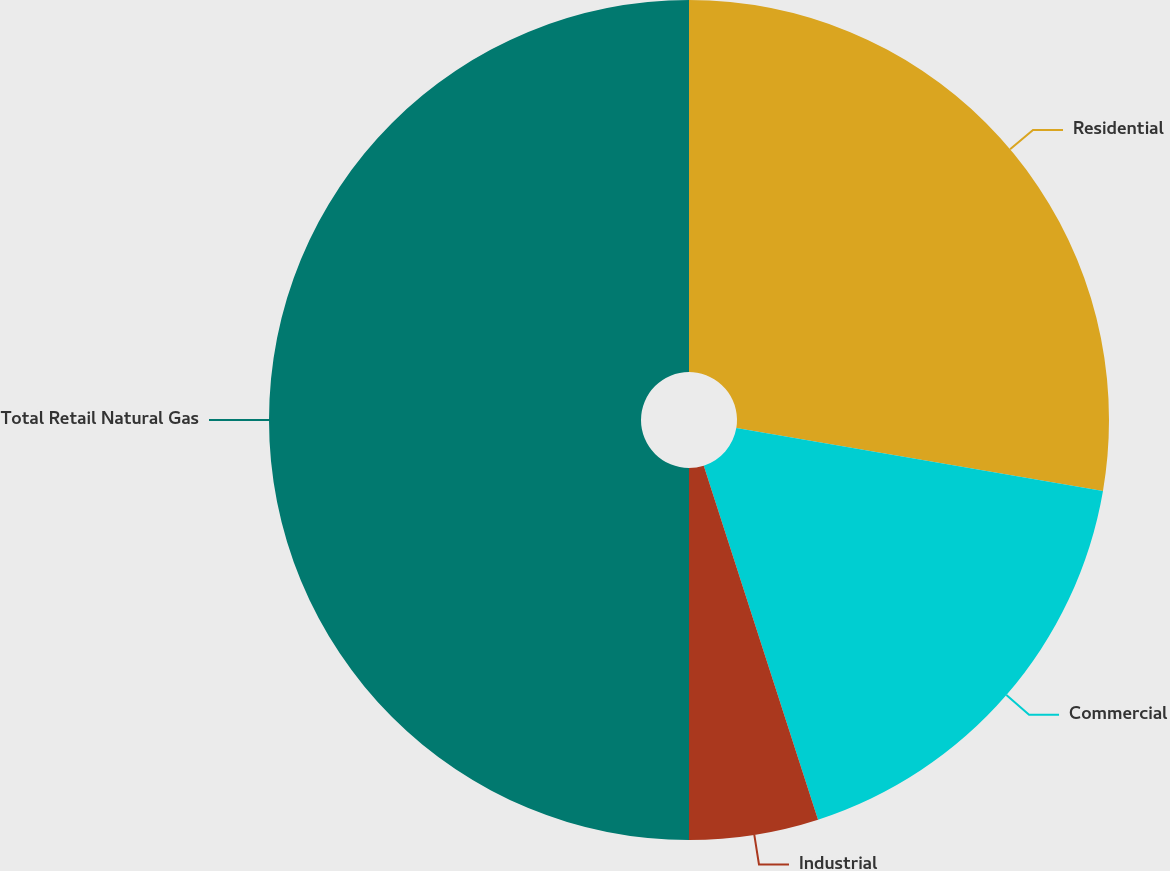Convert chart to OTSL. <chart><loc_0><loc_0><loc_500><loc_500><pie_chart><fcel>Residential<fcel>Commercial<fcel>Industrial<fcel>Total Retail Natural Gas<nl><fcel>27.7%<fcel>17.33%<fcel>4.97%<fcel>50.0%<nl></chart> 